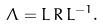<formula> <loc_0><loc_0><loc_500><loc_500>\Lambda = L \, R \, L ^ { - 1 } .</formula> 